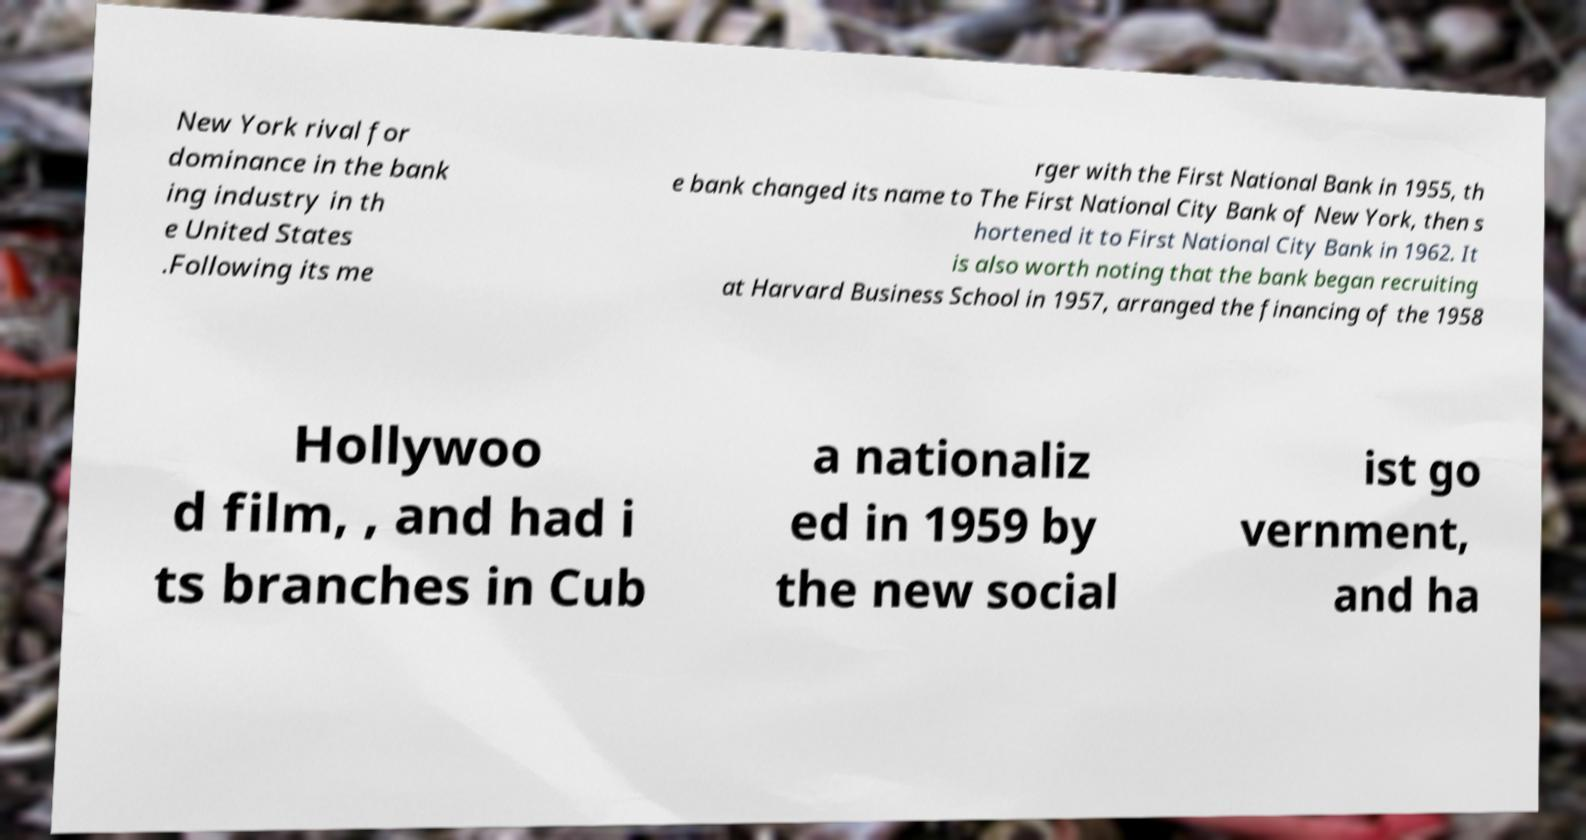Could you extract and type out the text from this image? New York rival for dominance in the bank ing industry in th e United States .Following its me rger with the First National Bank in 1955, th e bank changed its name to The First National City Bank of New York, then s hortened it to First National City Bank in 1962. It is also worth noting that the bank began recruiting at Harvard Business School in 1957, arranged the financing of the 1958 Hollywoo d film, , and had i ts branches in Cub a nationaliz ed in 1959 by the new social ist go vernment, and ha 